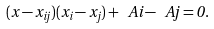Convert formula to latex. <formula><loc_0><loc_0><loc_500><loc_500>( x - x _ { i j } ) ( x _ { i } - x _ { j } ) + \ A { i } - \ A { j } = 0 .</formula> 